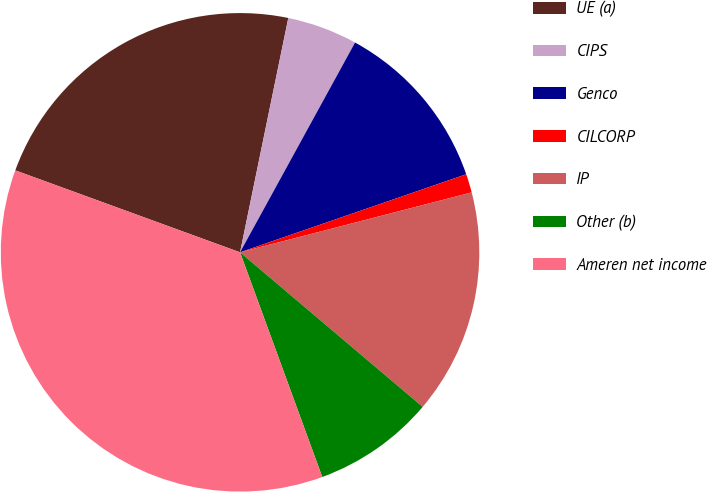Convert chart to OTSL. <chart><loc_0><loc_0><loc_500><loc_500><pie_chart><fcel>UE (a)<fcel>CIPS<fcel>Genco<fcel>CILCORP<fcel>IP<fcel>Other (b)<fcel>Ameren net income<nl><fcel>22.67%<fcel>4.75%<fcel>11.73%<fcel>1.26%<fcel>15.21%<fcel>8.24%<fcel>36.15%<nl></chart> 